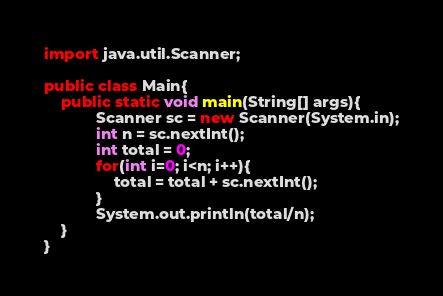Convert code to text. <code><loc_0><loc_0><loc_500><loc_500><_Java_>import java.util.Scanner;

public class Main{
    public static void main(String[] args){
			Scanner sc = new Scanner(System.in);
			int n = sc.nextInt();
      		int total = 0;
      		for(int i=0; i<n; i++){ 
			 	total = total + sc.nextInt();
            }
      		System.out.println(total/n);
    }
}

</code> 